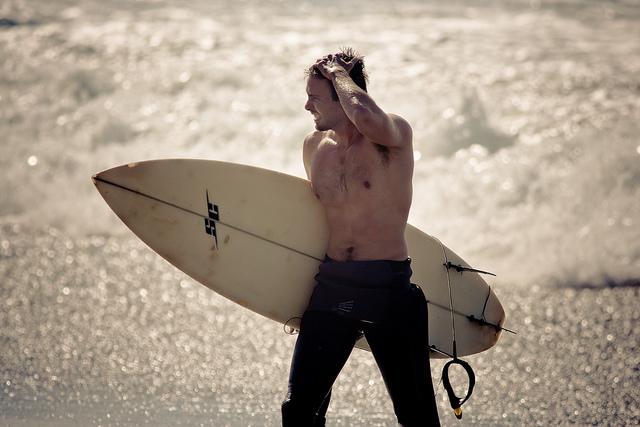What is he doing?
Write a very short answer. Surfing. Is the surf big?
Concise answer only. Yes. Is this man trying to show off his muscles?
Quick response, please. No. What letters are on the surfboard?
Be succinct. Sc. Why wear a wetsuit?
Be succinct. No. 